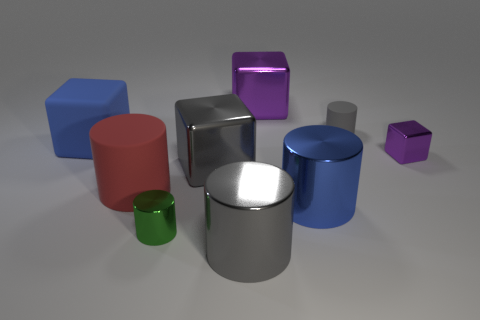Can you describe the differences in textures among the objects? Certainly! Looking at the image, the textures vary among the objects. The big red cylinder has a smooth, glossy finish similar to the small green cylinder and the large silver cylinder, exhibiting sharp reflections. The blue cube, smaller purple cube, and the small purple cylinder have a matte finish with soft, diffused reflections, while the large blue cylinder has a metallic sheen that is distinct from both the glossy and matte objects. 